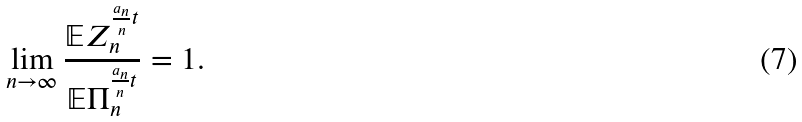Convert formula to latex. <formula><loc_0><loc_0><loc_500><loc_500>\lim _ { n \rightarrow \infty } \frac { \mathbb { E } Z _ { n } ^ { \frac { a _ { n } } { n } t } } { \mathbb { E } \Pi _ { n } ^ { \frac { a _ { n } } { n } t } } = 1 .</formula> 